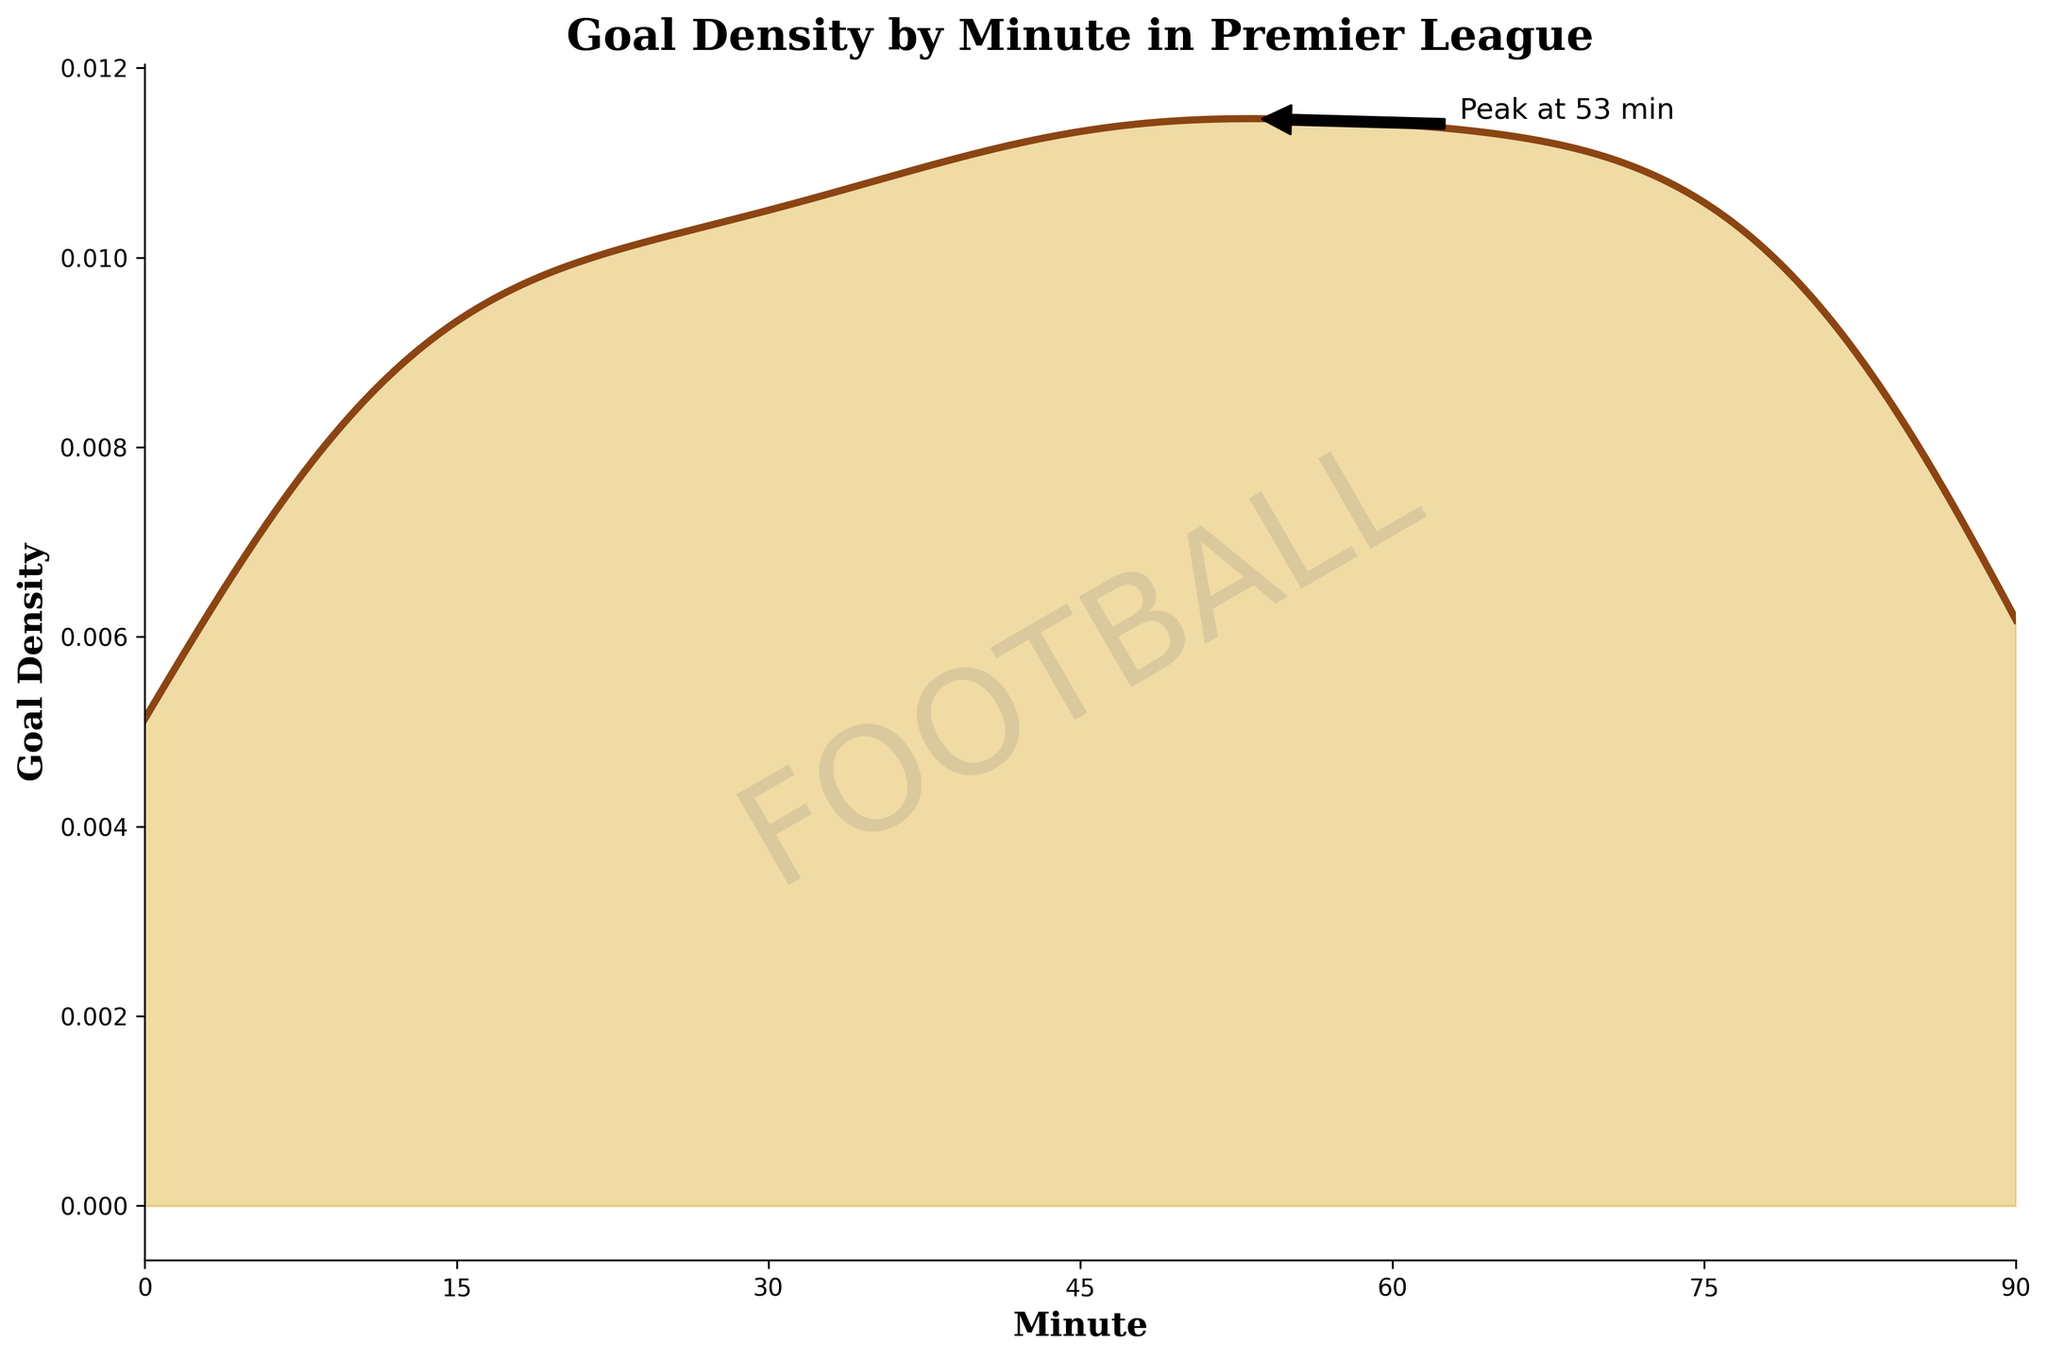What is the title of the figure? The title is typically displayed at the top of the figure. It gives a summary of what the figure is about.
Answer: Goal Density by Minute in Premier League What do the x-axis and y-axis represent in the figure? The x-axis and y-axis labels are usually found along the bottom and the side of the figure, respectively.
Answer: The x-axis represents the minute, and the y-axis represents the goal density What color is used to fill the area under the density curve? Observing the area under the curve will show the color used to fill it.
Answer: Golden color At which minute is the 'peak time' indicated by the annotation? The annotation marks the peak value on the density curve with a text label and an arrow.
Answer: 45 minutes What does the ‘peak time’ annotation mean? The annotation falls on the peak of the density curve. This point is where the curve reaches the highest value, indicating the peak goal-scoring density.
Answer: It indicates the minute with the highest goal density How does the goal density change from the 1st minute to the 45th minute? By looking at the density curve from the start to the middle (1st minute to the 45th minute), you can see if it generally increases, decreases, or stays the same.
Answer: The goal density generally increases Is there any noticeable drop in goal density after the peak time? Check the density curve after the peak time to see if it significantly decreases.
Answer: Yes How would you describe the trend of goal density in the first 15 minutes compared to the last 15 minutes? You can compare the density curve in the first 15 minutes with the last 15 minutes by observing their respective sections.
Answer: The first 15 minutes show a lower goal density compared to the last 15 minutes At which intervals (0-45 or 45-90 minutes) do we see a more significant change in goal density? By examining the density curve in both halves of the match, you can identify where the most significant changes occur.
Answer: 45-90 minutes What does the watermark 'FOOTBALL' represent in the figure? The watermark text is often used for aesthetic or thematic purposes.
Answer: It adds a football-themed visual element 